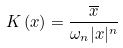Convert formula to latex. <formula><loc_0><loc_0><loc_500><loc_500>K \left ( x \right ) = \frac { \overline { x } } { \omega _ { n } | x | ^ { n } }</formula> 